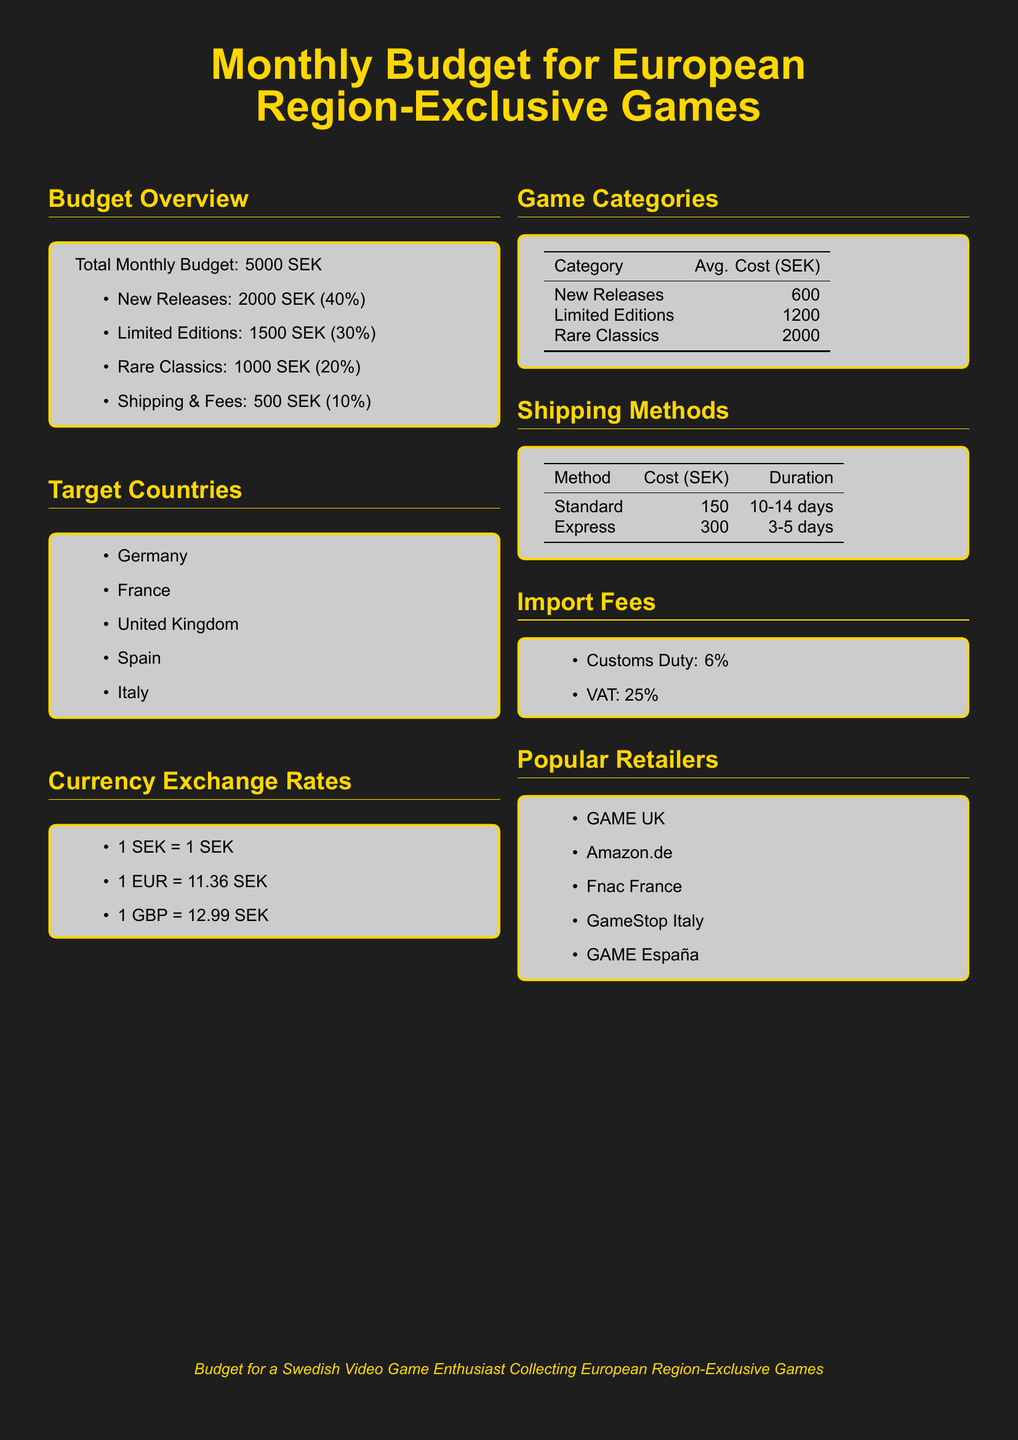What is the total monthly budget? The total monthly budget is clearly listed in the document under the Budget Overview section.
Answer: 5000 SEK How much is allocated for new releases? The document specifies how much of the budget is allocated for new releases under the Budget Overview section.
Answer: 2000 SEK What is the average cost of limited editions? The average cost for limited editions is presented in the Game Categories section.
Answer: 1200 SEK What is the shipping cost for the standard method? The cost of shipping using the standard method is detailed in the Shipping Methods section.
Answer: 150 SEK What is the import VAT percentage? The import VAT percentage is mentioned in the Import Fees section of the document.
Answer: 25% Which country is in the target countries list? One of the target countries is listed in the Target Countries section.
Answer: Germany What is the average cost of rare classics? The document provides the average cost of rare classics in the Game Categories section.
Answer: 2000 SEK How many countries are mentioned in the target countries section? The document lists the target countries, and the count can be found in the Target Countries section.
Answer: 5 What is the duration of express shipping? The duration for express shipping is indicated in the Shipping Methods section.
Answer: 3-5 days 